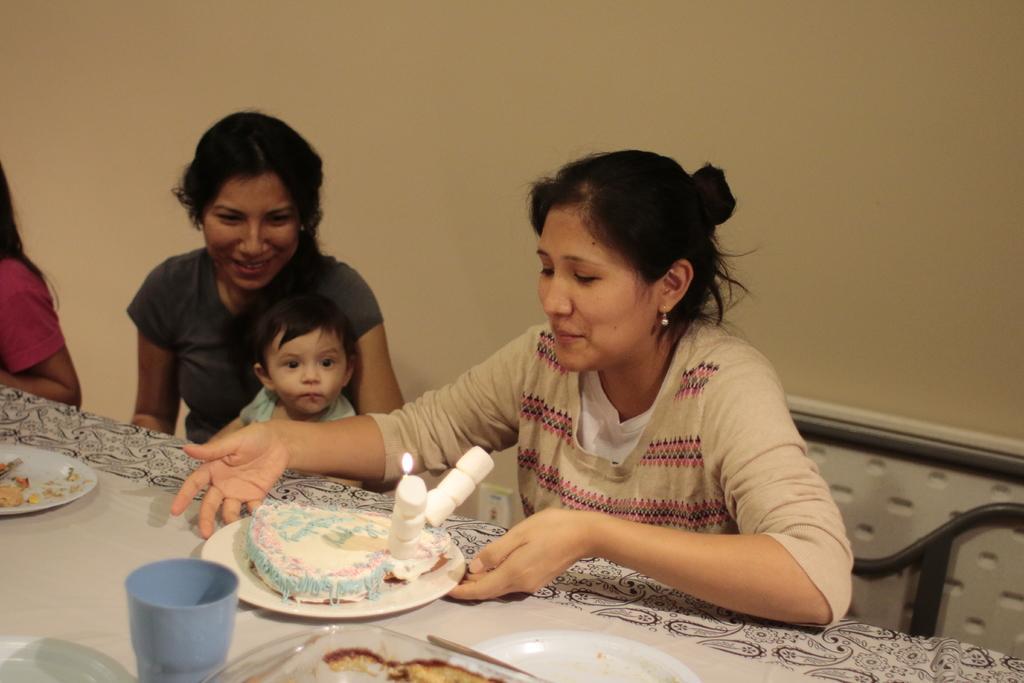Can you describe this image briefly? There are two women sitting on the chairs and smiling. This is a small baby. This looks like a table with plates, glass and few things on it. This plate contains a cake with a candle. I think this is the wall. At the left corner of the image, I can see a person. 